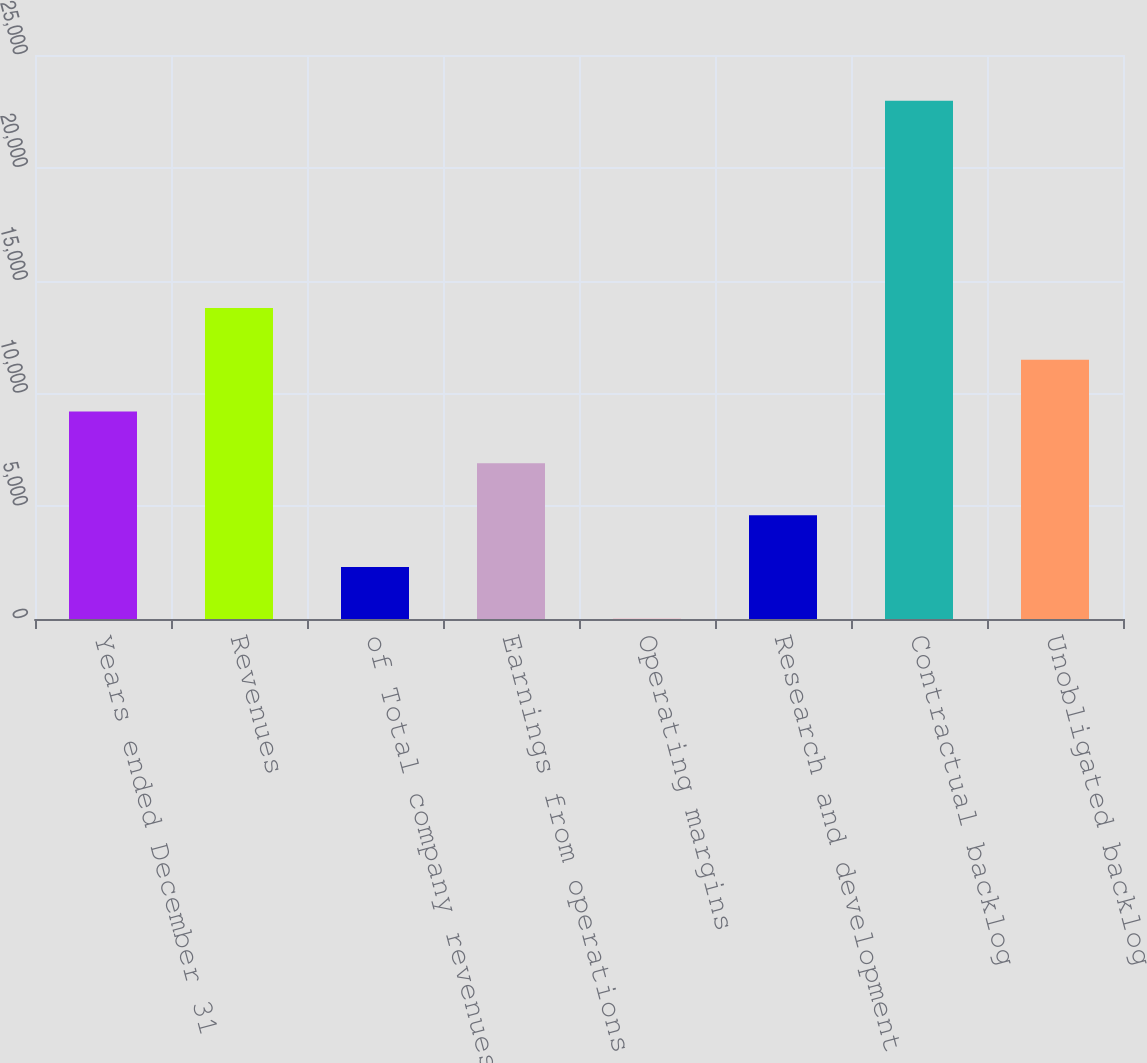Convert chart. <chart><loc_0><loc_0><loc_500><loc_500><bar_chart><fcel>Years ended December 31<fcel>Revenues<fcel>of Total company revenues<fcel>Earnings from operations<fcel>Operating margins<fcel>Research and development<fcel>Contractual backlog<fcel>Unobligated backlog<nl><fcel>9196.74<fcel>13789.2<fcel>2308.11<fcel>6900.53<fcel>11.9<fcel>4604.32<fcel>22974<fcel>11493<nl></chart> 